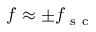<formula> <loc_0><loc_0><loc_500><loc_500>f \approx \pm f _ { s c }</formula> 